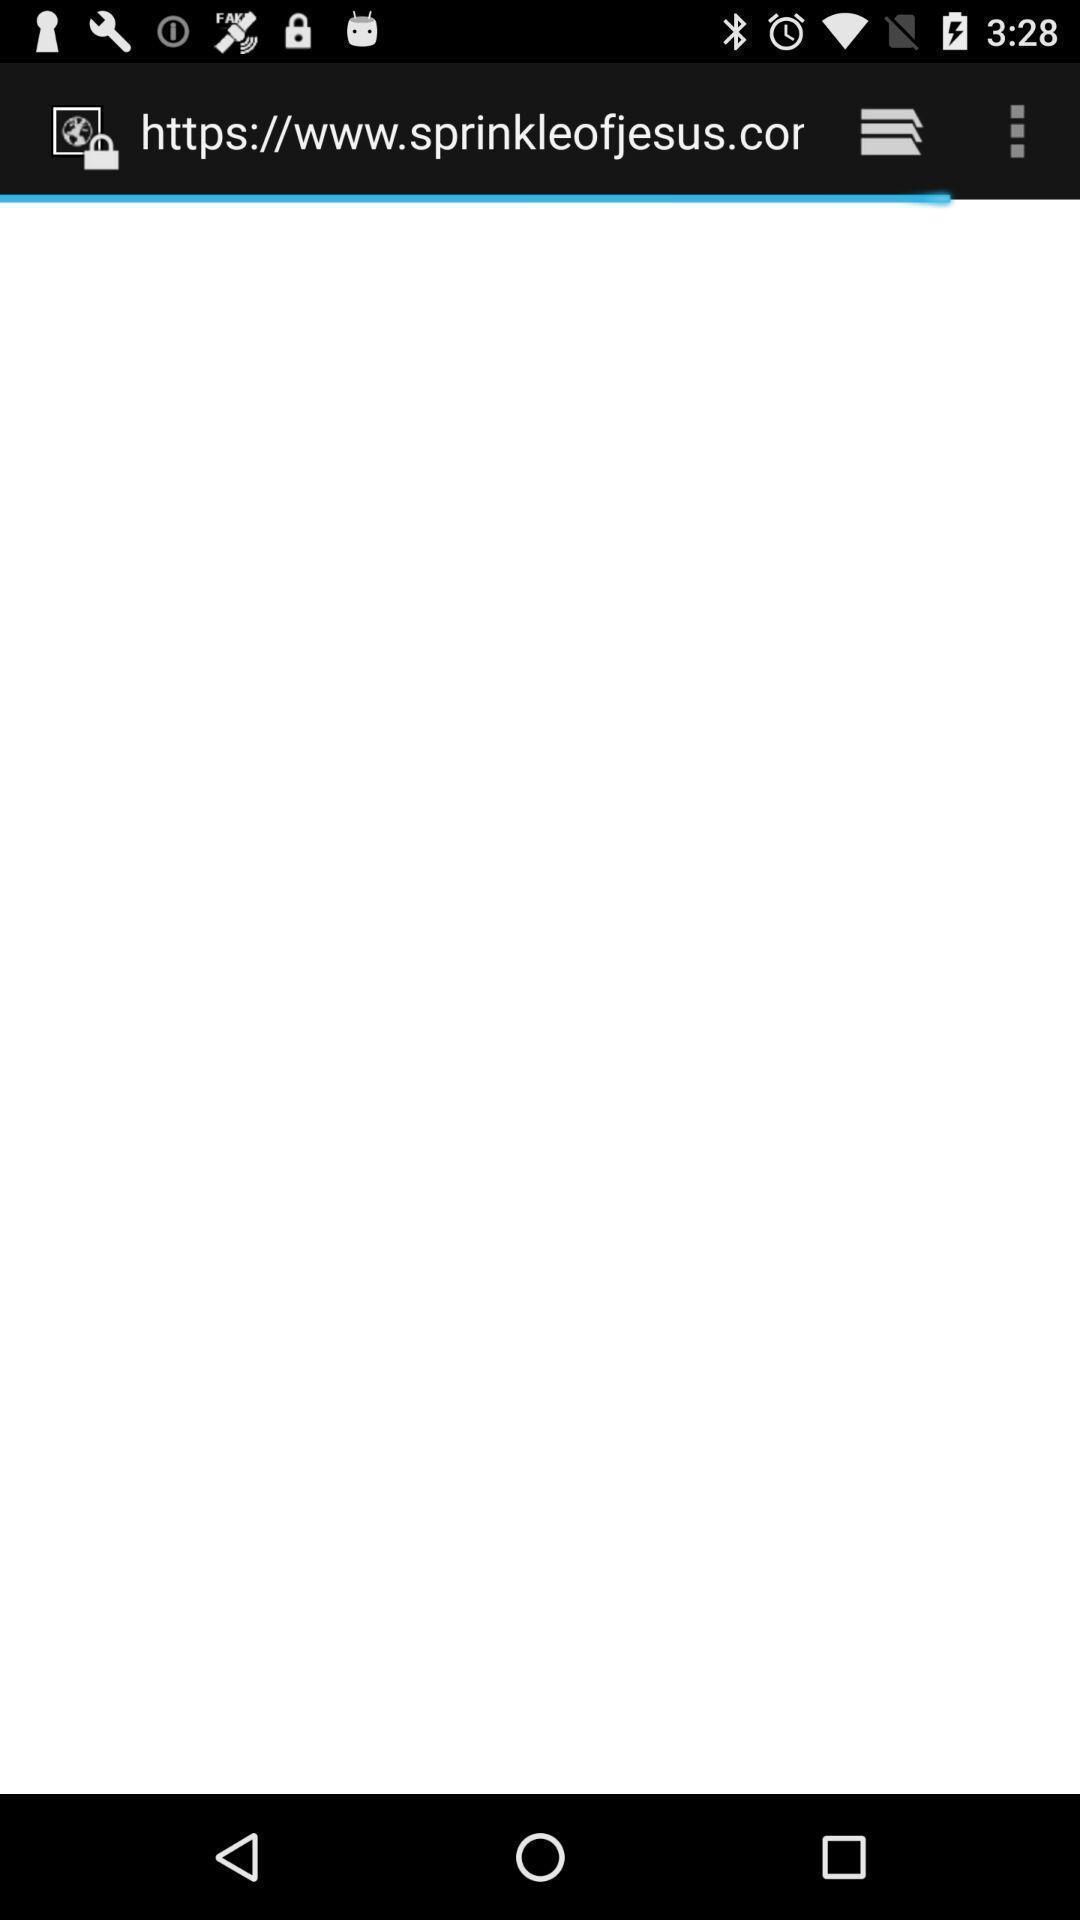Give me a narrative description of this picture. Screen shows a blank browsing page. 